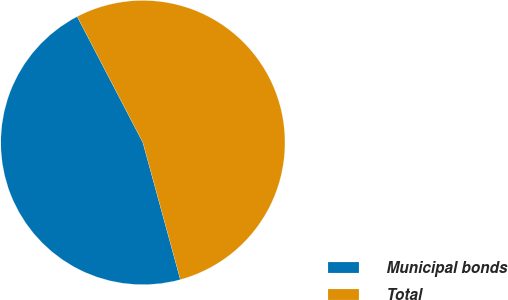Convert chart to OTSL. <chart><loc_0><loc_0><loc_500><loc_500><pie_chart><fcel>Municipal bonds<fcel>Total<nl><fcel>46.6%<fcel>53.4%<nl></chart> 